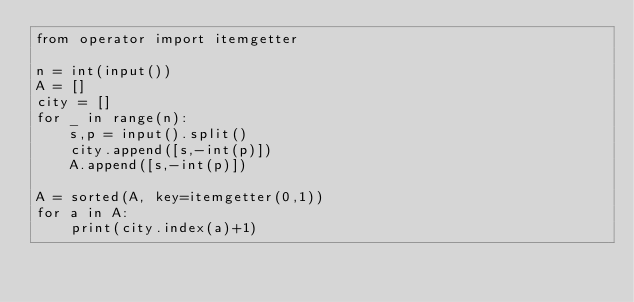Convert code to text. <code><loc_0><loc_0><loc_500><loc_500><_Python_>from operator import itemgetter

n = int(input())
A = []
city = []
for _ in range(n):
    s,p = input().split()
    city.append([s,-int(p)])
    A.append([s,-int(p)])

A = sorted(A, key=itemgetter(0,1))
for a in A:
    print(city.index(a)+1)</code> 